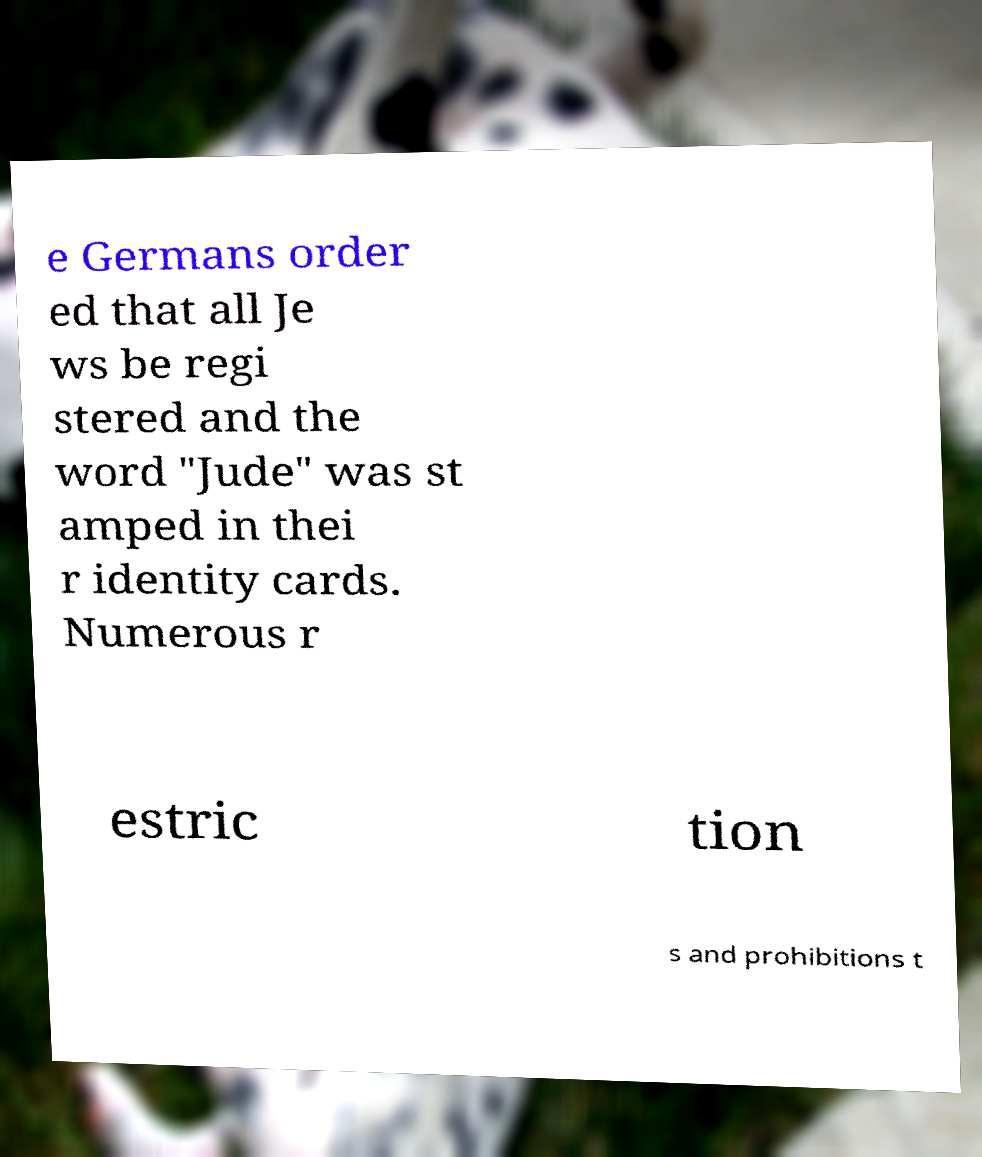For documentation purposes, I need the text within this image transcribed. Could you provide that? e Germans order ed that all Je ws be regi stered and the word "Jude" was st amped in thei r identity cards. Numerous r estric tion s and prohibitions t 